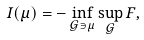<formula> <loc_0><loc_0><loc_500><loc_500>I ( \mu ) = - \inf _ { \mathcal { G } \ni \mu } \sup _ { \mathcal { G } } F ,</formula> 